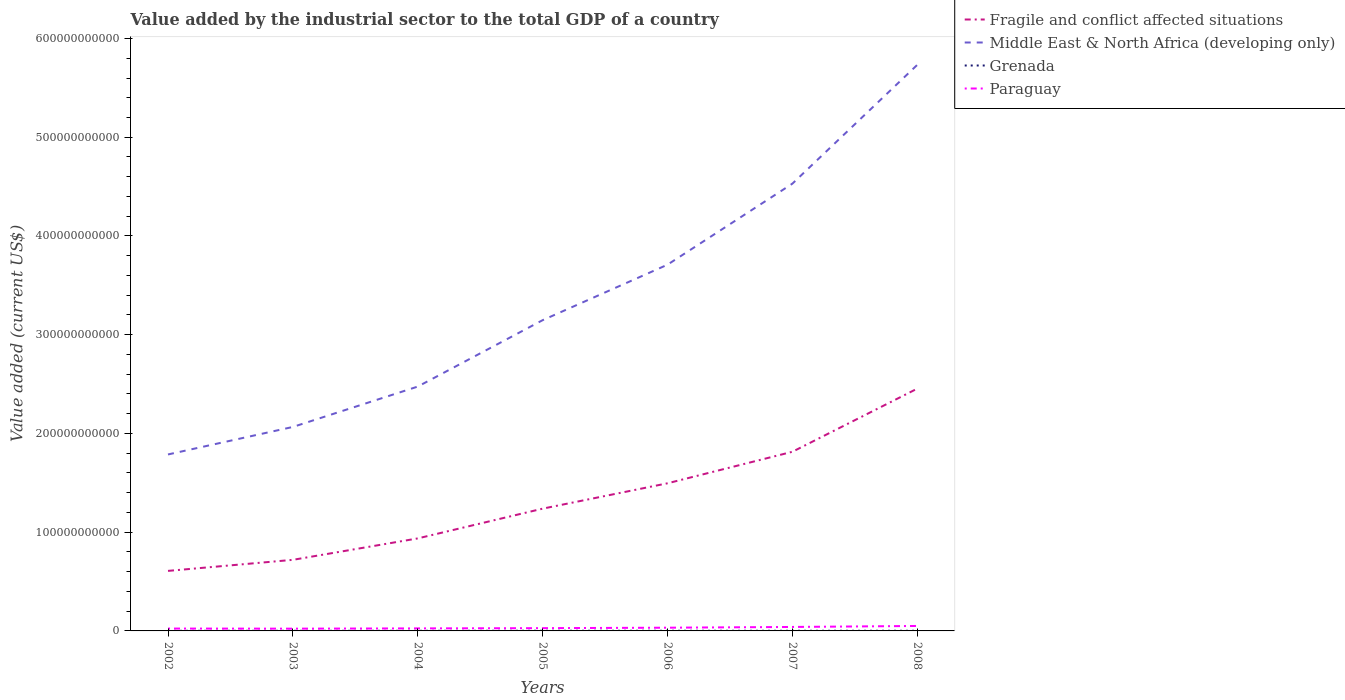How many different coloured lines are there?
Offer a terse response. 4. Is the number of lines equal to the number of legend labels?
Your answer should be very brief. Yes. Across all years, what is the maximum value added by the industrial sector to the total GDP in Paraguay?
Give a very brief answer. 2.29e+09. In which year was the value added by the industrial sector to the total GDP in Grenada maximum?
Your answer should be compact. 2002. What is the total value added by the industrial sector to the total GDP in Paraguay in the graph?
Your answer should be compact. -2.49e+08. What is the difference between the highest and the second highest value added by the industrial sector to the total GDP in Middle East & North Africa (developing only)?
Offer a very short reply. 3.95e+11. What is the difference between the highest and the lowest value added by the industrial sector to the total GDP in Grenada?
Provide a short and direct response. 4. Is the value added by the industrial sector to the total GDP in Fragile and conflict affected situations strictly greater than the value added by the industrial sector to the total GDP in Paraguay over the years?
Your response must be concise. No. How many lines are there?
Your response must be concise. 4. What is the difference between two consecutive major ticks on the Y-axis?
Your response must be concise. 1.00e+11. Does the graph contain any zero values?
Give a very brief answer. No. Does the graph contain grids?
Your answer should be compact. No. Where does the legend appear in the graph?
Provide a short and direct response. Top right. What is the title of the graph?
Ensure brevity in your answer.  Value added by the industrial sector to the total GDP of a country. What is the label or title of the Y-axis?
Your answer should be very brief. Value added (current US$). What is the Value added (current US$) of Fragile and conflict affected situations in 2002?
Offer a terse response. 6.08e+1. What is the Value added (current US$) of Middle East & North Africa (developing only) in 2002?
Give a very brief answer. 1.79e+11. What is the Value added (current US$) in Grenada in 2002?
Offer a very short reply. 8.98e+07. What is the Value added (current US$) of Paraguay in 2002?
Your answer should be very brief. 2.40e+09. What is the Value added (current US$) in Fragile and conflict affected situations in 2003?
Your response must be concise. 7.20e+1. What is the Value added (current US$) in Middle East & North Africa (developing only) in 2003?
Your answer should be very brief. 2.07e+11. What is the Value added (current US$) in Grenada in 2003?
Make the answer very short. 1.01e+08. What is the Value added (current US$) of Paraguay in 2003?
Ensure brevity in your answer.  2.29e+09. What is the Value added (current US$) in Fragile and conflict affected situations in 2004?
Provide a short and direct response. 9.37e+1. What is the Value added (current US$) of Middle East & North Africa (developing only) in 2004?
Your response must be concise. 2.47e+11. What is the Value added (current US$) in Grenada in 2004?
Keep it short and to the point. 1.00e+08. What is the Value added (current US$) in Paraguay in 2004?
Provide a short and direct response. 2.56e+09. What is the Value added (current US$) of Fragile and conflict affected situations in 2005?
Offer a very short reply. 1.24e+11. What is the Value added (current US$) of Middle East & North Africa (developing only) in 2005?
Provide a succinct answer. 3.15e+11. What is the Value added (current US$) in Grenada in 2005?
Offer a very short reply. 1.59e+08. What is the Value added (current US$) in Paraguay in 2005?
Keep it short and to the point. 2.81e+09. What is the Value added (current US$) of Fragile and conflict affected situations in 2006?
Your answer should be very brief. 1.50e+11. What is the Value added (current US$) in Middle East & North Africa (developing only) in 2006?
Offer a terse response. 3.71e+11. What is the Value added (current US$) of Grenada in 2006?
Keep it short and to the point. 1.36e+08. What is the Value added (current US$) of Paraguay in 2006?
Ensure brevity in your answer.  3.27e+09. What is the Value added (current US$) of Fragile and conflict affected situations in 2007?
Your answer should be very brief. 1.81e+11. What is the Value added (current US$) of Middle East & North Africa (developing only) in 2007?
Your answer should be very brief. 4.53e+11. What is the Value added (current US$) in Grenada in 2007?
Make the answer very short. 1.43e+08. What is the Value added (current US$) in Paraguay in 2007?
Your answer should be compact. 4.01e+09. What is the Value added (current US$) in Fragile and conflict affected situations in 2008?
Provide a succinct answer. 2.45e+11. What is the Value added (current US$) of Middle East & North Africa (developing only) in 2008?
Ensure brevity in your answer.  5.73e+11. What is the Value added (current US$) of Grenada in 2008?
Make the answer very short. 1.45e+08. What is the Value added (current US$) in Paraguay in 2008?
Your response must be concise. 5.03e+09. Across all years, what is the maximum Value added (current US$) of Fragile and conflict affected situations?
Ensure brevity in your answer.  2.45e+11. Across all years, what is the maximum Value added (current US$) of Middle East & North Africa (developing only)?
Provide a short and direct response. 5.73e+11. Across all years, what is the maximum Value added (current US$) in Grenada?
Make the answer very short. 1.59e+08. Across all years, what is the maximum Value added (current US$) in Paraguay?
Your response must be concise. 5.03e+09. Across all years, what is the minimum Value added (current US$) of Fragile and conflict affected situations?
Your answer should be compact. 6.08e+1. Across all years, what is the minimum Value added (current US$) in Middle East & North Africa (developing only)?
Your answer should be compact. 1.79e+11. Across all years, what is the minimum Value added (current US$) in Grenada?
Offer a very short reply. 8.98e+07. Across all years, what is the minimum Value added (current US$) in Paraguay?
Give a very brief answer. 2.29e+09. What is the total Value added (current US$) of Fragile and conflict affected situations in the graph?
Your response must be concise. 9.27e+11. What is the total Value added (current US$) of Middle East & North Africa (developing only) in the graph?
Give a very brief answer. 2.34e+12. What is the total Value added (current US$) in Grenada in the graph?
Offer a very short reply. 8.73e+08. What is the total Value added (current US$) in Paraguay in the graph?
Give a very brief answer. 2.24e+1. What is the difference between the Value added (current US$) of Fragile and conflict affected situations in 2002 and that in 2003?
Ensure brevity in your answer.  -1.12e+1. What is the difference between the Value added (current US$) in Middle East & North Africa (developing only) in 2002 and that in 2003?
Ensure brevity in your answer.  -2.79e+1. What is the difference between the Value added (current US$) of Grenada in 2002 and that in 2003?
Keep it short and to the point. -1.07e+07. What is the difference between the Value added (current US$) in Paraguay in 2002 and that in 2003?
Provide a succinct answer. 1.13e+08. What is the difference between the Value added (current US$) of Fragile and conflict affected situations in 2002 and that in 2004?
Offer a terse response. -3.29e+1. What is the difference between the Value added (current US$) of Middle East & North Africa (developing only) in 2002 and that in 2004?
Your answer should be very brief. -6.88e+1. What is the difference between the Value added (current US$) in Grenada in 2002 and that in 2004?
Ensure brevity in your answer.  -1.03e+07. What is the difference between the Value added (current US$) in Paraguay in 2002 and that in 2004?
Provide a succinct answer. -1.56e+08. What is the difference between the Value added (current US$) in Fragile and conflict affected situations in 2002 and that in 2005?
Provide a short and direct response. -6.30e+1. What is the difference between the Value added (current US$) in Middle East & North Africa (developing only) in 2002 and that in 2005?
Provide a succinct answer. -1.36e+11. What is the difference between the Value added (current US$) in Grenada in 2002 and that in 2005?
Provide a succinct answer. -6.91e+07. What is the difference between the Value added (current US$) of Paraguay in 2002 and that in 2005?
Make the answer very short. -4.05e+08. What is the difference between the Value added (current US$) in Fragile and conflict affected situations in 2002 and that in 2006?
Give a very brief answer. -8.87e+1. What is the difference between the Value added (current US$) in Middle East & North Africa (developing only) in 2002 and that in 2006?
Make the answer very short. -1.92e+11. What is the difference between the Value added (current US$) of Grenada in 2002 and that in 2006?
Offer a very short reply. -4.59e+07. What is the difference between the Value added (current US$) of Paraguay in 2002 and that in 2006?
Provide a short and direct response. -8.67e+08. What is the difference between the Value added (current US$) in Fragile and conflict affected situations in 2002 and that in 2007?
Your answer should be very brief. -1.21e+11. What is the difference between the Value added (current US$) of Middle East & North Africa (developing only) in 2002 and that in 2007?
Ensure brevity in your answer.  -2.74e+11. What is the difference between the Value added (current US$) in Grenada in 2002 and that in 2007?
Provide a succinct answer. -5.30e+07. What is the difference between the Value added (current US$) of Paraguay in 2002 and that in 2007?
Provide a short and direct response. -1.61e+09. What is the difference between the Value added (current US$) in Fragile and conflict affected situations in 2002 and that in 2008?
Ensure brevity in your answer.  -1.85e+11. What is the difference between the Value added (current US$) of Middle East & North Africa (developing only) in 2002 and that in 2008?
Provide a short and direct response. -3.95e+11. What is the difference between the Value added (current US$) in Grenada in 2002 and that in 2008?
Provide a short and direct response. -5.52e+07. What is the difference between the Value added (current US$) in Paraguay in 2002 and that in 2008?
Offer a terse response. -2.63e+09. What is the difference between the Value added (current US$) in Fragile and conflict affected situations in 2003 and that in 2004?
Offer a terse response. -2.17e+1. What is the difference between the Value added (current US$) of Middle East & North Africa (developing only) in 2003 and that in 2004?
Offer a very short reply. -4.09e+1. What is the difference between the Value added (current US$) of Grenada in 2003 and that in 2004?
Offer a very short reply. 4.01e+05. What is the difference between the Value added (current US$) in Paraguay in 2003 and that in 2004?
Your response must be concise. -2.69e+08. What is the difference between the Value added (current US$) in Fragile and conflict affected situations in 2003 and that in 2005?
Provide a short and direct response. -5.18e+1. What is the difference between the Value added (current US$) of Middle East & North Africa (developing only) in 2003 and that in 2005?
Offer a terse response. -1.08e+11. What is the difference between the Value added (current US$) in Grenada in 2003 and that in 2005?
Provide a short and direct response. -5.84e+07. What is the difference between the Value added (current US$) in Paraguay in 2003 and that in 2005?
Provide a short and direct response. -5.18e+08. What is the difference between the Value added (current US$) in Fragile and conflict affected situations in 2003 and that in 2006?
Ensure brevity in your answer.  -7.75e+1. What is the difference between the Value added (current US$) of Middle East & North Africa (developing only) in 2003 and that in 2006?
Keep it short and to the point. -1.64e+11. What is the difference between the Value added (current US$) in Grenada in 2003 and that in 2006?
Provide a short and direct response. -3.52e+07. What is the difference between the Value added (current US$) in Paraguay in 2003 and that in 2006?
Keep it short and to the point. -9.80e+08. What is the difference between the Value added (current US$) of Fragile and conflict affected situations in 2003 and that in 2007?
Ensure brevity in your answer.  -1.09e+11. What is the difference between the Value added (current US$) in Middle East & North Africa (developing only) in 2003 and that in 2007?
Keep it short and to the point. -2.46e+11. What is the difference between the Value added (current US$) of Grenada in 2003 and that in 2007?
Give a very brief answer. -4.22e+07. What is the difference between the Value added (current US$) in Paraguay in 2003 and that in 2007?
Provide a short and direct response. -1.73e+09. What is the difference between the Value added (current US$) in Fragile and conflict affected situations in 2003 and that in 2008?
Provide a succinct answer. -1.73e+11. What is the difference between the Value added (current US$) of Middle East & North Africa (developing only) in 2003 and that in 2008?
Give a very brief answer. -3.67e+11. What is the difference between the Value added (current US$) in Grenada in 2003 and that in 2008?
Your response must be concise. -4.45e+07. What is the difference between the Value added (current US$) of Paraguay in 2003 and that in 2008?
Provide a short and direct response. -2.74e+09. What is the difference between the Value added (current US$) in Fragile and conflict affected situations in 2004 and that in 2005?
Your answer should be compact. -3.01e+1. What is the difference between the Value added (current US$) of Middle East & North Africa (developing only) in 2004 and that in 2005?
Your answer should be very brief. -6.72e+1. What is the difference between the Value added (current US$) in Grenada in 2004 and that in 2005?
Ensure brevity in your answer.  -5.88e+07. What is the difference between the Value added (current US$) in Paraguay in 2004 and that in 2005?
Ensure brevity in your answer.  -2.49e+08. What is the difference between the Value added (current US$) of Fragile and conflict affected situations in 2004 and that in 2006?
Make the answer very short. -5.58e+1. What is the difference between the Value added (current US$) of Middle East & North Africa (developing only) in 2004 and that in 2006?
Ensure brevity in your answer.  -1.23e+11. What is the difference between the Value added (current US$) of Grenada in 2004 and that in 2006?
Your response must be concise. -3.56e+07. What is the difference between the Value added (current US$) in Paraguay in 2004 and that in 2006?
Provide a short and direct response. -7.11e+08. What is the difference between the Value added (current US$) in Fragile and conflict affected situations in 2004 and that in 2007?
Provide a succinct answer. -8.77e+1. What is the difference between the Value added (current US$) of Middle East & North Africa (developing only) in 2004 and that in 2007?
Ensure brevity in your answer.  -2.06e+11. What is the difference between the Value added (current US$) of Grenada in 2004 and that in 2007?
Keep it short and to the point. -4.26e+07. What is the difference between the Value added (current US$) in Paraguay in 2004 and that in 2007?
Make the answer very short. -1.46e+09. What is the difference between the Value added (current US$) of Fragile and conflict affected situations in 2004 and that in 2008?
Make the answer very short. -1.52e+11. What is the difference between the Value added (current US$) in Middle East & North Africa (developing only) in 2004 and that in 2008?
Keep it short and to the point. -3.26e+11. What is the difference between the Value added (current US$) in Grenada in 2004 and that in 2008?
Your answer should be very brief. -4.49e+07. What is the difference between the Value added (current US$) in Paraguay in 2004 and that in 2008?
Offer a terse response. -2.47e+09. What is the difference between the Value added (current US$) in Fragile and conflict affected situations in 2005 and that in 2006?
Your response must be concise. -2.57e+1. What is the difference between the Value added (current US$) of Middle East & North Africa (developing only) in 2005 and that in 2006?
Keep it short and to the point. -5.62e+1. What is the difference between the Value added (current US$) in Grenada in 2005 and that in 2006?
Ensure brevity in your answer.  2.32e+07. What is the difference between the Value added (current US$) in Paraguay in 2005 and that in 2006?
Your answer should be compact. -4.62e+08. What is the difference between the Value added (current US$) in Fragile and conflict affected situations in 2005 and that in 2007?
Offer a terse response. -5.76e+1. What is the difference between the Value added (current US$) of Middle East & North Africa (developing only) in 2005 and that in 2007?
Offer a very short reply. -1.38e+11. What is the difference between the Value added (current US$) of Grenada in 2005 and that in 2007?
Your answer should be compact. 1.61e+07. What is the difference between the Value added (current US$) of Paraguay in 2005 and that in 2007?
Offer a very short reply. -1.21e+09. What is the difference between the Value added (current US$) of Fragile and conflict affected situations in 2005 and that in 2008?
Offer a terse response. -1.22e+11. What is the difference between the Value added (current US$) of Middle East & North Africa (developing only) in 2005 and that in 2008?
Provide a succinct answer. -2.59e+11. What is the difference between the Value added (current US$) in Grenada in 2005 and that in 2008?
Your answer should be compact. 1.39e+07. What is the difference between the Value added (current US$) of Paraguay in 2005 and that in 2008?
Make the answer very short. -2.22e+09. What is the difference between the Value added (current US$) in Fragile and conflict affected situations in 2006 and that in 2007?
Your answer should be very brief. -3.19e+1. What is the difference between the Value added (current US$) of Middle East & North Africa (developing only) in 2006 and that in 2007?
Ensure brevity in your answer.  -8.20e+1. What is the difference between the Value added (current US$) in Grenada in 2006 and that in 2007?
Offer a very short reply. -7.07e+06. What is the difference between the Value added (current US$) of Paraguay in 2006 and that in 2007?
Provide a succinct answer. -7.46e+08. What is the difference between the Value added (current US$) of Fragile and conflict affected situations in 2006 and that in 2008?
Your answer should be compact. -9.59e+1. What is the difference between the Value added (current US$) of Middle East & North Africa (developing only) in 2006 and that in 2008?
Offer a terse response. -2.02e+11. What is the difference between the Value added (current US$) in Grenada in 2006 and that in 2008?
Offer a very short reply. -9.29e+06. What is the difference between the Value added (current US$) in Paraguay in 2006 and that in 2008?
Provide a short and direct response. -1.76e+09. What is the difference between the Value added (current US$) of Fragile and conflict affected situations in 2007 and that in 2008?
Give a very brief answer. -6.40e+1. What is the difference between the Value added (current US$) of Middle East & North Africa (developing only) in 2007 and that in 2008?
Make the answer very short. -1.20e+11. What is the difference between the Value added (current US$) in Grenada in 2007 and that in 2008?
Keep it short and to the point. -2.22e+06. What is the difference between the Value added (current US$) in Paraguay in 2007 and that in 2008?
Your answer should be very brief. -1.01e+09. What is the difference between the Value added (current US$) of Fragile and conflict affected situations in 2002 and the Value added (current US$) of Middle East & North Africa (developing only) in 2003?
Ensure brevity in your answer.  -1.46e+11. What is the difference between the Value added (current US$) in Fragile and conflict affected situations in 2002 and the Value added (current US$) in Grenada in 2003?
Offer a terse response. 6.07e+1. What is the difference between the Value added (current US$) in Fragile and conflict affected situations in 2002 and the Value added (current US$) in Paraguay in 2003?
Keep it short and to the point. 5.85e+1. What is the difference between the Value added (current US$) in Middle East & North Africa (developing only) in 2002 and the Value added (current US$) in Grenada in 2003?
Ensure brevity in your answer.  1.79e+11. What is the difference between the Value added (current US$) of Middle East & North Africa (developing only) in 2002 and the Value added (current US$) of Paraguay in 2003?
Ensure brevity in your answer.  1.76e+11. What is the difference between the Value added (current US$) of Grenada in 2002 and the Value added (current US$) of Paraguay in 2003?
Your answer should be compact. -2.20e+09. What is the difference between the Value added (current US$) in Fragile and conflict affected situations in 2002 and the Value added (current US$) in Middle East & North Africa (developing only) in 2004?
Provide a short and direct response. -1.87e+11. What is the difference between the Value added (current US$) of Fragile and conflict affected situations in 2002 and the Value added (current US$) of Grenada in 2004?
Offer a very short reply. 6.07e+1. What is the difference between the Value added (current US$) in Fragile and conflict affected situations in 2002 and the Value added (current US$) in Paraguay in 2004?
Your response must be concise. 5.82e+1. What is the difference between the Value added (current US$) in Middle East & North Africa (developing only) in 2002 and the Value added (current US$) in Grenada in 2004?
Provide a succinct answer. 1.79e+11. What is the difference between the Value added (current US$) in Middle East & North Africa (developing only) in 2002 and the Value added (current US$) in Paraguay in 2004?
Offer a terse response. 1.76e+11. What is the difference between the Value added (current US$) in Grenada in 2002 and the Value added (current US$) in Paraguay in 2004?
Ensure brevity in your answer.  -2.47e+09. What is the difference between the Value added (current US$) in Fragile and conflict affected situations in 2002 and the Value added (current US$) in Middle East & North Africa (developing only) in 2005?
Give a very brief answer. -2.54e+11. What is the difference between the Value added (current US$) in Fragile and conflict affected situations in 2002 and the Value added (current US$) in Grenada in 2005?
Ensure brevity in your answer.  6.06e+1. What is the difference between the Value added (current US$) in Fragile and conflict affected situations in 2002 and the Value added (current US$) in Paraguay in 2005?
Your answer should be compact. 5.80e+1. What is the difference between the Value added (current US$) of Middle East & North Africa (developing only) in 2002 and the Value added (current US$) of Grenada in 2005?
Your response must be concise. 1.79e+11. What is the difference between the Value added (current US$) of Middle East & North Africa (developing only) in 2002 and the Value added (current US$) of Paraguay in 2005?
Offer a very short reply. 1.76e+11. What is the difference between the Value added (current US$) of Grenada in 2002 and the Value added (current US$) of Paraguay in 2005?
Ensure brevity in your answer.  -2.72e+09. What is the difference between the Value added (current US$) of Fragile and conflict affected situations in 2002 and the Value added (current US$) of Middle East & North Africa (developing only) in 2006?
Provide a succinct answer. -3.10e+11. What is the difference between the Value added (current US$) in Fragile and conflict affected situations in 2002 and the Value added (current US$) in Grenada in 2006?
Provide a short and direct response. 6.07e+1. What is the difference between the Value added (current US$) in Fragile and conflict affected situations in 2002 and the Value added (current US$) in Paraguay in 2006?
Keep it short and to the point. 5.75e+1. What is the difference between the Value added (current US$) in Middle East & North Africa (developing only) in 2002 and the Value added (current US$) in Grenada in 2006?
Your answer should be very brief. 1.79e+11. What is the difference between the Value added (current US$) in Middle East & North Africa (developing only) in 2002 and the Value added (current US$) in Paraguay in 2006?
Provide a succinct answer. 1.75e+11. What is the difference between the Value added (current US$) in Grenada in 2002 and the Value added (current US$) in Paraguay in 2006?
Offer a very short reply. -3.18e+09. What is the difference between the Value added (current US$) of Fragile and conflict affected situations in 2002 and the Value added (current US$) of Middle East & North Africa (developing only) in 2007?
Provide a succinct answer. -3.92e+11. What is the difference between the Value added (current US$) of Fragile and conflict affected situations in 2002 and the Value added (current US$) of Grenada in 2007?
Provide a succinct answer. 6.07e+1. What is the difference between the Value added (current US$) of Fragile and conflict affected situations in 2002 and the Value added (current US$) of Paraguay in 2007?
Provide a short and direct response. 5.68e+1. What is the difference between the Value added (current US$) in Middle East & North Africa (developing only) in 2002 and the Value added (current US$) in Grenada in 2007?
Your response must be concise. 1.79e+11. What is the difference between the Value added (current US$) in Middle East & North Africa (developing only) in 2002 and the Value added (current US$) in Paraguay in 2007?
Give a very brief answer. 1.75e+11. What is the difference between the Value added (current US$) of Grenada in 2002 and the Value added (current US$) of Paraguay in 2007?
Provide a succinct answer. -3.92e+09. What is the difference between the Value added (current US$) of Fragile and conflict affected situations in 2002 and the Value added (current US$) of Middle East & North Africa (developing only) in 2008?
Keep it short and to the point. -5.13e+11. What is the difference between the Value added (current US$) in Fragile and conflict affected situations in 2002 and the Value added (current US$) in Grenada in 2008?
Ensure brevity in your answer.  6.07e+1. What is the difference between the Value added (current US$) in Fragile and conflict affected situations in 2002 and the Value added (current US$) in Paraguay in 2008?
Provide a short and direct response. 5.58e+1. What is the difference between the Value added (current US$) in Middle East & North Africa (developing only) in 2002 and the Value added (current US$) in Grenada in 2008?
Offer a very short reply. 1.79e+11. What is the difference between the Value added (current US$) in Middle East & North Africa (developing only) in 2002 and the Value added (current US$) in Paraguay in 2008?
Your answer should be compact. 1.74e+11. What is the difference between the Value added (current US$) in Grenada in 2002 and the Value added (current US$) in Paraguay in 2008?
Your answer should be compact. -4.94e+09. What is the difference between the Value added (current US$) in Fragile and conflict affected situations in 2003 and the Value added (current US$) in Middle East & North Africa (developing only) in 2004?
Offer a very short reply. -1.75e+11. What is the difference between the Value added (current US$) in Fragile and conflict affected situations in 2003 and the Value added (current US$) in Grenada in 2004?
Make the answer very short. 7.19e+1. What is the difference between the Value added (current US$) in Fragile and conflict affected situations in 2003 and the Value added (current US$) in Paraguay in 2004?
Your response must be concise. 6.94e+1. What is the difference between the Value added (current US$) of Middle East & North Africa (developing only) in 2003 and the Value added (current US$) of Grenada in 2004?
Keep it short and to the point. 2.06e+11. What is the difference between the Value added (current US$) in Middle East & North Africa (developing only) in 2003 and the Value added (current US$) in Paraguay in 2004?
Your response must be concise. 2.04e+11. What is the difference between the Value added (current US$) of Grenada in 2003 and the Value added (current US$) of Paraguay in 2004?
Ensure brevity in your answer.  -2.46e+09. What is the difference between the Value added (current US$) in Fragile and conflict affected situations in 2003 and the Value added (current US$) in Middle East & North Africa (developing only) in 2005?
Your answer should be compact. -2.43e+11. What is the difference between the Value added (current US$) in Fragile and conflict affected situations in 2003 and the Value added (current US$) in Grenada in 2005?
Give a very brief answer. 7.18e+1. What is the difference between the Value added (current US$) of Fragile and conflict affected situations in 2003 and the Value added (current US$) of Paraguay in 2005?
Your answer should be compact. 6.92e+1. What is the difference between the Value added (current US$) of Middle East & North Africa (developing only) in 2003 and the Value added (current US$) of Grenada in 2005?
Provide a succinct answer. 2.06e+11. What is the difference between the Value added (current US$) in Middle East & North Africa (developing only) in 2003 and the Value added (current US$) in Paraguay in 2005?
Make the answer very short. 2.04e+11. What is the difference between the Value added (current US$) in Grenada in 2003 and the Value added (current US$) in Paraguay in 2005?
Ensure brevity in your answer.  -2.71e+09. What is the difference between the Value added (current US$) of Fragile and conflict affected situations in 2003 and the Value added (current US$) of Middle East & North Africa (developing only) in 2006?
Give a very brief answer. -2.99e+11. What is the difference between the Value added (current US$) of Fragile and conflict affected situations in 2003 and the Value added (current US$) of Grenada in 2006?
Offer a very short reply. 7.19e+1. What is the difference between the Value added (current US$) in Fragile and conflict affected situations in 2003 and the Value added (current US$) in Paraguay in 2006?
Make the answer very short. 6.87e+1. What is the difference between the Value added (current US$) of Middle East & North Africa (developing only) in 2003 and the Value added (current US$) of Grenada in 2006?
Your answer should be compact. 2.06e+11. What is the difference between the Value added (current US$) of Middle East & North Africa (developing only) in 2003 and the Value added (current US$) of Paraguay in 2006?
Offer a terse response. 2.03e+11. What is the difference between the Value added (current US$) of Grenada in 2003 and the Value added (current US$) of Paraguay in 2006?
Your response must be concise. -3.17e+09. What is the difference between the Value added (current US$) of Fragile and conflict affected situations in 2003 and the Value added (current US$) of Middle East & North Africa (developing only) in 2007?
Your answer should be very brief. -3.81e+11. What is the difference between the Value added (current US$) in Fragile and conflict affected situations in 2003 and the Value added (current US$) in Grenada in 2007?
Provide a short and direct response. 7.19e+1. What is the difference between the Value added (current US$) in Fragile and conflict affected situations in 2003 and the Value added (current US$) in Paraguay in 2007?
Keep it short and to the point. 6.80e+1. What is the difference between the Value added (current US$) in Middle East & North Africa (developing only) in 2003 and the Value added (current US$) in Grenada in 2007?
Your response must be concise. 2.06e+11. What is the difference between the Value added (current US$) in Middle East & North Africa (developing only) in 2003 and the Value added (current US$) in Paraguay in 2007?
Provide a succinct answer. 2.03e+11. What is the difference between the Value added (current US$) in Grenada in 2003 and the Value added (current US$) in Paraguay in 2007?
Your response must be concise. -3.91e+09. What is the difference between the Value added (current US$) in Fragile and conflict affected situations in 2003 and the Value added (current US$) in Middle East & North Africa (developing only) in 2008?
Keep it short and to the point. -5.01e+11. What is the difference between the Value added (current US$) of Fragile and conflict affected situations in 2003 and the Value added (current US$) of Grenada in 2008?
Ensure brevity in your answer.  7.19e+1. What is the difference between the Value added (current US$) of Fragile and conflict affected situations in 2003 and the Value added (current US$) of Paraguay in 2008?
Your answer should be very brief. 6.70e+1. What is the difference between the Value added (current US$) of Middle East & North Africa (developing only) in 2003 and the Value added (current US$) of Grenada in 2008?
Offer a terse response. 2.06e+11. What is the difference between the Value added (current US$) of Middle East & North Africa (developing only) in 2003 and the Value added (current US$) of Paraguay in 2008?
Ensure brevity in your answer.  2.02e+11. What is the difference between the Value added (current US$) of Grenada in 2003 and the Value added (current US$) of Paraguay in 2008?
Your answer should be compact. -4.93e+09. What is the difference between the Value added (current US$) in Fragile and conflict affected situations in 2004 and the Value added (current US$) in Middle East & North Africa (developing only) in 2005?
Offer a terse response. -2.21e+11. What is the difference between the Value added (current US$) of Fragile and conflict affected situations in 2004 and the Value added (current US$) of Grenada in 2005?
Your response must be concise. 9.35e+1. What is the difference between the Value added (current US$) of Fragile and conflict affected situations in 2004 and the Value added (current US$) of Paraguay in 2005?
Provide a succinct answer. 9.09e+1. What is the difference between the Value added (current US$) in Middle East & North Africa (developing only) in 2004 and the Value added (current US$) in Grenada in 2005?
Offer a very short reply. 2.47e+11. What is the difference between the Value added (current US$) of Middle East & North Africa (developing only) in 2004 and the Value added (current US$) of Paraguay in 2005?
Your response must be concise. 2.45e+11. What is the difference between the Value added (current US$) in Grenada in 2004 and the Value added (current US$) in Paraguay in 2005?
Your answer should be very brief. -2.71e+09. What is the difference between the Value added (current US$) of Fragile and conflict affected situations in 2004 and the Value added (current US$) of Middle East & North Africa (developing only) in 2006?
Provide a short and direct response. -2.77e+11. What is the difference between the Value added (current US$) in Fragile and conflict affected situations in 2004 and the Value added (current US$) in Grenada in 2006?
Ensure brevity in your answer.  9.36e+1. What is the difference between the Value added (current US$) of Fragile and conflict affected situations in 2004 and the Value added (current US$) of Paraguay in 2006?
Your answer should be very brief. 9.04e+1. What is the difference between the Value added (current US$) in Middle East & North Africa (developing only) in 2004 and the Value added (current US$) in Grenada in 2006?
Make the answer very short. 2.47e+11. What is the difference between the Value added (current US$) of Middle East & North Africa (developing only) in 2004 and the Value added (current US$) of Paraguay in 2006?
Provide a succinct answer. 2.44e+11. What is the difference between the Value added (current US$) of Grenada in 2004 and the Value added (current US$) of Paraguay in 2006?
Offer a terse response. -3.17e+09. What is the difference between the Value added (current US$) of Fragile and conflict affected situations in 2004 and the Value added (current US$) of Middle East & North Africa (developing only) in 2007?
Keep it short and to the point. -3.59e+11. What is the difference between the Value added (current US$) of Fragile and conflict affected situations in 2004 and the Value added (current US$) of Grenada in 2007?
Make the answer very short. 9.36e+1. What is the difference between the Value added (current US$) in Fragile and conflict affected situations in 2004 and the Value added (current US$) in Paraguay in 2007?
Your answer should be very brief. 8.97e+1. What is the difference between the Value added (current US$) of Middle East & North Africa (developing only) in 2004 and the Value added (current US$) of Grenada in 2007?
Your response must be concise. 2.47e+11. What is the difference between the Value added (current US$) in Middle East & North Africa (developing only) in 2004 and the Value added (current US$) in Paraguay in 2007?
Offer a very short reply. 2.43e+11. What is the difference between the Value added (current US$) in Grenada in 2004 and the Value added (current US$) in Paraguay in 2007?
Offer a terse response. -3.91e+09. What is the difference between the Value added (current US$) of Fragile and conflict affected situations in 2004 and the Value added (current US$) of Middle East & North Africa (developing only) in 2008?
Ensure brevity in your answer.  -4.80e+11. What is the difference between the Value added (current US$) of Fragile and conflict affected situations in 2004 and the Value added (current US$) of Grenada in 2008?
Your response must be concise. 9.36e+1. What is the difference between the Value added (current US$) of Fragile and conflict affected situations in 2004 and the Value added (current US$) of Paraguay in 2008?
Give a very brief answer. 8.87e+1. What is the difference between the Value added (current US$) in Middle East & North Africa (developing only) in 2004 and the Value added (current US$) in Grenada in 2008?
Your answer should be compact. 2.47e+11. What is the difference between the Value added (current US$) of Middle East & North Africa (developing only) in 2004 and the Value added (current US$) of Paraguay in 2008?
Your answer should be compact. 2.42e+11. What is the difference between the Value added (current US$) of Grenada in 2004 and the Value added (current US$) of Paraguay in 2008?
Give a very brief answer. -4.93e+09. What is the difference between the Value added (current US$) of Fragile and conflict affected situations in 2005 and the Value added (current US$) of Middle East & North Africa (developing only) in 2006?
Give a very brief answer. -2.47e+11. What is the difference between the Value added (current US$) in Fragile and conflict affected situations in 2005 and the Value added (current US$) in Grenada in 2006?
Your answer should be compact. 1.24e+11. What is the difference between the Value added (current US$) in Fragile and conflict affected situations in 2005 and the Value added (current US$) in Paraguay in 2006?
Offer a terse response. 1.21e+11. What is the difference between the Value added (current US$) in Middle East & North Africa (developing only) in 2005 and the Value added (current US$) in Grenada in 2006?
Offer a very short reply. 3.15e+11. What is the difference between the Value added (current US$) of Middle East & North Africa (developing only) in 2005 and the Value added (current US$) of Paraguay in 2006?
Ensure brevity in your answer.  3.11e+11. What is the difference between the Value added (current US$) of Grenada in 2005 and the Value added (current US$) of Paraguay in 2006?
Provide a short and direct response. -3.11e+09. What is the difference between the Value added (current US$) of Fragile and conflict affected situations in 2005 and the Value added (current US$) of Middle East & North Africa (developing only) in 2007?
Your response must be concise. -3.29e+11. What is the difference between the Value added (current US$) of Fragile and conflict affected situations in 2005 and the Value added (current US$) of Grenada in 2007?
Offer a very short reply. 1.24e+11. What is the difference between the Value added (current US$) in Fragile and conflict affected situations in 2005 and the Value added (current US$) in Paraguay in 2007?
Provide a short and direct response. 1.20e+11. What is the difference between the Value added (current US$) of Middle East & North Africa (developing only) in 2005 and the Value added (current US$) of Grenada in 2007?
Provide a succinct answer. 3.15e+11. What is the difference between the Value added (current US$) of Middle East & North Africa (developing only) in 2005 and the Value added (current US$) of Paraguay in 2007?
Your response must be concise. 3.11e+11. What is the difference between the Value added (current US$) of Grenada in 2005 and the Value added (current US$) of Paraguay in 2007?
Give a very brief answer. -3.86e+09. What is the difference between the Value added (current US$) of Fragile and conflict affected situations in 2005 and the Value added (current US$) of Middle East & North Africa (developing only) in 2008?
Provide a succinct answer. -4.49e+11. What is the difference between the Value added (current US$) of Fragile and conflict affected situations in 2005 and the Value added (current US$) of Grenada in 2008?
Offer a terse response. 1.24e+11. What is the difference between the Value added (current US$) of Fragile and conflict affected situations in 2005 and the Value added (current US$) of Paraguay in 2008?
Provide a short and direct response. 1.19e+11. What is the difference between the Value added (current US$) in Middle East & North Africa (developing only) in 2005 and the Value added (current US$) in Grenada in 2008?
Provide a succinct answer. 3.15e+11. What is the difference between the Value added (current US$) in Middle East & North Africa (developing only) in 2005 and the Value added (current US$) in Paraguay in 2008?
Offer a terse response. 3.10e+11. What is the difference between the Value added (current US$) of Grenada in 2005 and the Value added (current US$) of Paraguay in 2008?
Keep it short and to the point. -4.87e+09. What is the difference between the Value added (current US$) of Fragile and conflict affected situations in 2006 and the Value added (current US$) of Middle East & North Africa (developing only) in 2007?
Your answer should be very brief. -3.03e+11. What is the difference between the Value added (current US$) of Fragile and conflict affected situations in 2006 and the Value added (current US$) of Grenada in 2007?
Offer a terse response. 1.49e+11. What is the difference between the Value added (current US$) in Fragile and conflict affected situations in 2006 and the Value added (current US$) in Paraguay in 2007?
Ensure brevity in your answer.  1.46e+11. What is the difference between the Value added (current US$) of Middle East & North Africa (developing only) in 2006 and the Value added (current US$) of Grenada in 2007?
Offer a very short reply. 3.71e+11. What is the difference between the Value added (current US$) in Middle East & North Africa (developing only) in 2006 and the Value added (current US$) in Paraguay in 2007?
Ensure brevity in your answer.  3.67e+11. What is the difference between the Value added (current US$) of Grenada in 2006 and the Value added (current US$) of Paraguay in 2007?
Ensure brevity in your answer.  -3.88e+09. What is the difference between the Value added (current US$) in Fragile and conflict affected situations in 2006 and the Value added (current US$) in Middle East & North Africa (developing only) in 2008?
Ensure brevity in your answer.  -4.24e+11. What is the difference between the Value added (current US$) in Fragile and conflict affected situations in 2006 and the Value added (current US$) in Grenada in 2008?
Offer a terse response. 1.49e+11. What is the difference between the Value added (current US$) of Fragile and conflict affected situations in 2006 and the Value added (current US$) of Paraguay in 2008?
Keep it short and to the point. 1.44e+11. What is the difference between the Value added (current US$) of Middle East & North Africa (developing only) in 2006 and the Value added (current US$) of Grenada in 2008?
Provide a succinct answer. 3.71e+11. What is the difference between the Value added (current US$) of Middle East & North Africa (developing only) in 2006 and the Value added (current US$) of Paraguay in 2008?
Provide a short and direct response. 3.66e+11. What is the difference between the Value added (current US$) of Grenada in 2006 and the Value added (current US$) of Paraguay in 2008?
Make the answer very short. -4.89e+09. What is the difference between the Value added (current US$) in Fragile and conflict affected situations in 2007 and the Value added (current US$) in Middle East & North Africa (developing only) in 2008?
Make the answer very short. -3.92e+11. What is the difference between the Value added (current US$) of Fragile and conflict affected situations in 2007 and the Value added (current US$) of Grenada in 2008?
Keep it short and to the point. 1.81e+11. What is the difference between the Value added (current US$) in Fragile and conflict affected situations in 2007 and the Value added (current US$) in Paraguay in 2008?
Offer a terse response. 1.76e+11. What is the difference between the Value added (current US$) in Middle East & North Africa (developing only) in 2007 and the Value added (current US$) in Grenada in 2008?
Keep it short and to the point. 4.53e+11. What is the difference between the Value added (current US$) of Middle East & North Africa (developing only) in 2007 and the Value added (current US$) of Paraguay in 2008?
Offer a terse response. 4.48e+11. What is the difference between the Value added (current US$) in Grenada in 2007 and the Value added (current US$) in Paraguay in 2008?
Provide a succinct answer. -4.89e+09. What is the average Value added (current US$) in Fragile and conflict affected situations per year?
Ensure brevity in your answer.  1.32e+11. What is the average Value added (current US$) in Middle East & North Africa (developing only) per year?
Give a very brief answer. 3.35e+11. What is the average Value added (current US$) of Grenada per year?
Offer a terse response. 1.25e+08. What is the average Value added (current US$) of Paraguay per year?
Provide a short and direct response. 3.19e+09. In the year 2002, what is the difference between the Value added (current US$) of Fragile and conflict affected situations and Value added (current US$) of Middle East & North Africa (developing only)?
Provide a succinct answer. -1.18e+11. In the year 2002, what is the difference between the Value added (current US$) of Fragile and conflict affected situations and Value added (current US$) of Grenada?
Offer a very short reply. 6.07e+1. In the year 2002, what is the difference between the Value added (current US$) in Fragile and conflict affected situations and Value added (current US$) in Paraguay?
Ensure brevity in your answer.  5.84e+1. In the year 2002, what is the difference between the Value added (current US$) in Middle East & North Africa (developing only) and Value added (current US$) in Grenada?
Offer a terse response. 1.79e+11. In the year 2002, what is the difference between the Value added (current US$) in Middle East & North Africa (developing only) and Value added (current US$) in Paraguay?
Provide a short and direct response. 1.76e+11. In the year 2002, what is the difference between the Value added (current US$) of Grenada and Value added (current US$) of Paraguay?
Give a very brief answer. -2.31e+09. In the year 2003, what is the difference between the Value added (current US$) in Fragile and conflict affected situations and Value added (current US$) in Middle East & North Africa (developing only)?
Keep it short and to the point. -1.35e+11. In the year 2003, what is the difference between the Value added (current US$) of Fragile and conflict affected situations and Value added (current US$) of Grenada?
Provide a succinct answer. 7.19e+1. In the year 2003, what is the difference between the Value added (current US$) in Fragile and conflict affected situations and Value added (current US$) in Paraguay?
Your answer should be compact. 6.97e+1. In the year 2003, what is the difference between the Value added (current US$) in Middle East & North Africa (developing only) and Value added (current US$) in Grenada?
Offer a terse response. 2.06e+11. In the year 2003, what is the difference between the Value added (current US$) of Middle East & North Africa (developing only) and Value added (current US$) of Paraguay?
Provide a succinct answer. 2.04e+11. In the year 2003, what is the difference between the Value added (current US$) of Grenada and Value added (current US$) of Paraguay?
Provide a succinct answer. -2.19e+09. In the year 2004, what is the difference between the Value added (current US$) in Fragile and conflict affected situations and Value added (current US$) in Middle East & North Africa (developing only)?
Provide a short and direct response. -1.54e+11. In the year 2004, what is the difference between the Value added (current US$) in Fragile and conflict affected situations and Value added (current US$) in Grenada?
Provide a succinct answer. 9.36e+1. In the year 2004, what is the difference between the Value added (current US$) in Fragile and conflict affected situations and Value added (current US$) in Paraguay?
Provide a short and direct response. 9.11e+1. In the year 2004, what is the difference between the Value added (current US$) of Middle East & North Africa (developing only) and Value added (current US$) of Grenada?
Your answer should be compact. 2.47e+11. In the year 2004, what is the difference between the Value added (current US$) of Middle East & North Africa (developing only) and Value added (current US$) of Paraguay?
Ensure brevity in your answer.  2.45e+11. In the year 2004, what is the difference between the Value added (current US$) of Grenada and Value added (current US$) of Paraguay?
Provide a succinct answer. -2.46e+09. In the year 2005, what is the difference between the Value added (current US$) in Fragile and conflict affected situations and Value added (current US$) in Middle East & North Africa (developing only)?
Provide a short and direct response. -1.91e+11. In the year 2005, what is the difference between the Value added (current US$) in Fragile and conflict affected situations and Value added (current US$) in Grenada?
Offer a very short reply. 1.24e+11. In the year 2005, what is the difference between the Value added (current US$) in Fragile and conflict affected situations and Value added (current US$) in Paraguay?
Ensure brevity in your answer.  1.21e+11. In the year 2005, what is the difference between the Value added (current US$) of Middle East & North Africa (developing only) and Value added (current US$) of Grenada?
Keep it short and to the point. 3.15e+11. In the year 2005, what is the difference between the Value added (current US$) of Middle East & North Africa (developing only) and Value added (current US$) of Paraguay?
Ensure brevity in your answer.  3.12e+11. In the year 2005, what is the difference between the Value added (current US$) in Grenada and Value added (current US$) in Paraguay?
Offer a terse response. -2.65e+09. In the year 2006, what is the difference between the Value added (current US$) of Fragile and conflict affected situations and Value added (current US$) of Middle East & North Africa (developing only)?
Your answer should be very brief. -2.21e+11. In the year 2006, what is the difference between the Value added (current US$) of Fragile and conflict affected situations and Value added (current US$) of Grenada?
Offer a very short reply. 1.49e+11. In the year 2006, what is the difference between the Value added (current US$) in Fragile and conflict affected situations and Value added (current US$) in Paraguay?
Your answer should be compact. 1.46e+11. In the year 2006, what is the difference between the Value added (current US$) in Middle East & North Africa (developing only) and Value added (current US$) in Grenada?
Your response must be concise. 3.71e+11. In the year 2006, what is the difference between the Value added (current US$) in Middle East & North Africa (developing only) and Value added (current US$) in Paraguay?
Give a very brief answer. 3.68e+11. In the year 2006, what is the difference between the Value added (current US$) of Grenada and Value added (current US$) of Paraguay?
Your answer should be compact. -3.13e+09. In the year 2007, what is the difference between the Value added (current US$) in Fragile and conflict affected situations and Value added (current US$) in Middle East & North Africa (developing only)?
Offer a terse response. -2.72e+11. In the year 2007, what is the difference between the Value added (current US$) in Fragile and conflict affected situations and Value added (current US$) in Grenada?
Make the answer very short. 1.81e+11. In the year 2007, what is the difference between the Value added (current US$) in Fragile and conflict affected situations and Value added (current US$) in Paraguay?
Provide a succinct answer. 1.77e+11. In the year 2007, what is the difference between the Value added (current US$) of Middle East & North Africa (developing only) and Value added (current US$) of Grenada?
Offer a terse response. 4.53e+11. In the year 2007, what is the difference between the Value added (current US$) of Middle East & North Africa (developing only) and Value added (current US$) of Paraguay?
Provide a succinct answer. 4.49e+11. In the year 2007, what is the difference between the Value added (current US$) of Grenada and Value added (current US$) of Paraguay?
Ensure brevity in your answer.  -3.87e+09. In the year 2008, what is the difference between the Value added (current US$) in Fragile and conflict affected situations and Value added (current US$) in Middle East & North Africa (developing only)?
Your answer should be compact. -3.28e+11. In the year 2008, what is the difference between the Value added (current US$) in Fragile and conflict affected situations and Value added (current US$) in Grenada?
Your answer should be very brief. 2.45e+11. In the year 2008, what is the difference between the Value added (current US$) in Fragile and conflict affected situations and Value added (current US$) in Paraguay?
Your response must be concise. 2.40e+11. In the year 2008, what is the difference between the Value added (current US$) in Middle East & North Africa (developing only) and Value added (current US$) in Grenada?
Your answer should be compact. 5.73e+11. In the year 2008, what is the difference between the Value added (current US$) of Middle East & North Africa (developing only) and Value added (current US$) of Paraguay?
Provide a short and direct response. 5.68e+11. In the year 2008, what is the difference between the Value added (current US$) in Grenada and Value added (current US$) in Paraguay?
Offer a terse response. -4.88e+09. What is the ratio of the Value added (current US$) in Fragile and conflict affected situations in 2002 to that in 2003?
Give a very brief answer. 0.84. What is the ratio of the Value added (current US$) in Middle East & North Africa (developing only) in 2002 to that in 2003?
Your answer should be very brief. 0.87. What is the ratio of the Value added (current US$) in Grenada in 2002 to that in 2003?
Provide a short and direct response. 0.89. What is the ratio of the Value added (current US$) in Paraguay in 2002 to that in 2003?
Make the answer very short. 1.05. What is the ratio of the Value added (current US$) in Fragile and conflict affected situations in 2002 to that in 2004?
Keep it short and to the point. 0.65. What is the ratio of the Value added (current US$) in Middle East & North Africa (developing only) in 2002 to that in 2004?
Your answer should be compact. 0.72. What is the ratio of the Value added (current US$) of Grenada in 2002 to that in 2004?
Your response must be concise. 0.9. What is the ratio of the Value added (current US$) of Paraguay in 2002 to that in 2004?
Your response must be concise. 0.94. What is the ratio of the Value added (current US$) in Fragile and conflict affected situations in 2002 to that in 2005?
Ensure brevity in your answer.  0.49. What is the ratio of the Value added (current US$) in Middle East & North Africa (developing only) in 2002 to that in 2005?
Provide a short and direct response. 0.57. What is the ratio of the Value added (current US$) in Grenada in 2002 to that in 2005?
Make the answer very short. 0.56. What is the ratio of the Value added (current US$) of Paraguay in 2002 to that in 2005?
Make the answer very short. 0.86. What is the ratio of the Value added (current US$) of Fragile and conflict affected situations in 2002 to that in 2006?
Provide a short and direct response. 0.41. What is the ratio of the Value added (current US$) of Middle East & North Africa (developing only) in 2002 to that in 2006?
Make the answer very short. 0.48. What is the ratio of the Value added (current US$) in Grenada in 2002 to that in 2006?
Make the answer very short. 0.66. What is the ratio of the Value added (current US$) in Paraguay in 2002 to that in 2006?
Ensure brevity in your answer.  0.73. What is the ratio of the Value added (current US$) of Fragile and conflict affected situations in 2002 to that in 2007?
Offer a very short reply. 0.34. What is the ratio of the Value added (current US$) in Middle East & North Africa (developing only) in 2002 to that in 2007?
Make the answer very short. 0.39. What is the ratio of the Value added (current US$) in Grenada in 2002 to that in 2007?
Offer a terse response. 0.63. What is the ratio of the Value added (current US$) in Paraguay in 2002 to that in 2007?
Ensure brevity in your answer.  0.6. What is the ratio of the Value added (current US$) of Fragile and conflict affected situations in 2002 to that in 2008?
Your answer should be very brief. 0.25. What is the ratio of the Value added (current US$) in Middle East & North Africa (developing only) in 2002 to that in 2008?
Provide a succinct answer. 0.31. What is the ratio of the Value added (current US$) in Grenada in 2002 to that in 2008?
Offer a very short reply. 0.62. What is the ratio of the Value added (current US$) in Paraguay in 2002 to that in 2008?
Make the answer very short. 0.48. What is the ratio of the Value added (current US$) of Fragile and conflict affected situations in 2003 to that in 2004?
Give a very brief answer. 0.77. What is the ratio of the Value added (current US$) of Middle East & North Africa (developing only) in 2003 to that in 2004?
Your answer should be very brief. 0.83. What is the ratio of the Value added (current US$) of Grenada in 2003 to that in 2004?
Give a very brief answer. 1. What is the ratio of the Value added (current US$) of Paraguay in 2003 to that in 2004?
Make the answer very short. 0.89. What is the ratio of the Value added (current US$) in Fragile and conflict affected situations in 2003 to that in 2005?
Offer a very short reply. 0.58. What is the ratio of the Value added (current US$) of Middle East & North Africa (developing only) in 2003 to that in 2005?
Your answer should be very brief. 0.66. What is the ratio of the Value added (current US$) of Grenada in 2003 to that in 2005?
Ensure brevity in your answer.  0.63. What is the ratio of the Value added (current US$) in Paraguay in 2003 to that in 2005?
Make the answer very short. 0.82. What is the ratio of the Value added (current US$) in Fragile and conflict affected situations in 2003 to that in 2006?
Offer a very short reply. 0.48. What is the ratio of the Value added (current US$) of Middle East & North Africa (developing only) in 2003 to that in 2006?
Provide a short and direct response. 0.56. What is the ratio of the Value added (current US$) in Grenada in 2003 to that in 2006?
Your answer should be very brief. 0.74. What is the ratio of the Value added (current US$) in Paraguay in 2003 to that in 2006?
Keep it short and to the point. 0.7. What is the ratio of the Value added (current US$) of Fragile and conflict affected situations in 2003 to that in 2007?
Ensure brevity in your answer.  0.4. What is the ratio of the Value added (current US$) of Middle East & North Africa (developing only) in 2003 to that in 2007?
Provide a succinct answer. 0.46. What is the ratio of the Value added (current US$) of Grenada in 2003 to that in 2007?
Offer a terse response. 0.7. What is the ratio of the Value added (current US$) of Paraguay in 2003 to that in 2007?
Give a very brief answer. 0.57. What is the ratio of the Value added (current US$) of Fragile and conflict affected situations in 2003 to that in 2008?
Offer a very short reply. 0.29. What is the ratio of the Value added (current US$) of Middle East & North Africa (developing only) in 2003 to that in 2008?
Offer a terse response. 0.36. What is the ratio of the Value added (current US$) of Grenada in 2003 to that in 2008?
Your answer should be compact. 0.69. What is the ratio of the Value added (current US$) of Paraguay in 2003 to that in 2008?
Provide a short and direct response. 0.45. What is the ratio of the Value added (current US$) of Fragile and conflict affected situations in 2004 to that in 2005?
Your response must be concise. 0.76. What is the ratio of the Value added (current US$) in Middle East & North Africa (developing only) in 2004 to that in 2005?
Offer a very short reply. 0.79. What is the ratio of the Value added (current US$) of Grenada in 2004 to that in 2005?
Keep it short and to the point. 0.63. What is the ratio of the Value added (current US$) in Paraguay in 2004 to that in 2005?
Provide a succinct answer. 0.91. What is the ratio of the Value added (current US$) in Fragile and conflict affected situations in 2004 to that in 2006?
Give a very brief answer. 0.63. What is the ratio of the Value added (current US$) in Middle East & North Africa (developing only) in 2004 to that in 2006?
Provide a succinct answer. 0.67. What is the ratio of the Value added (current US$) in Grenada in 2004 to that in 2006?
Provide a short and direct response. 0.74. What is the ratio of the Value added (current US$) of Paraguay in 2004 to that in 2006?
Provide a succinct answer. 0.78. What is the ratio of the Value added (current US$) of Fragile and conflict affected situations in 2004 to that in 2007?
Provide a succinct answer. 0.52. What is the ratio of the Value added (current US$) in Middle East & North Africa (developing only) in 2004 to that in 2007?
Offer a terse response. 0.55. What is the ratio of the Value added (current US$) in Grenada in 2004 to that in 2007?
Offer a very short reply. 0.7. What is the ratio of the Value added (current US$) of Paraguay in 2004 to that in 2007?
Provide a short and direct response. 0.64. What is the ratio of the Value added (current US$) of Fragile and conflict affected situations in 2004 to that in 2008?
Make the answer very short. 0.38. What is the ratio of the Value added (current US$) of Middle East & North Africa (developing only) in 2004 to that in 2008?
Ensure brevity in your answer.  0.43. What is the ratio of the Value added (current US$) of Grenada in 2004 to that in 2008?
Give a very brief answer. 0.69. What is the ratio of the Value added (current US$) of Paraguay in 2004 to that in 2008?
Your answer should be compact. 0.51. What is the ratio of the Value added (current US$) of Fragile and conflict affected situations in 2005 to that in 2006?
Make the answer very short. 0.83. What is the ratio of the Value added (current US$) in Middle East & North Africa (developing only) in 2005 to that in 2006?
Your response must be concise. 0.85. What is the ratio of the Value added (current US$) of Grenada in 2005 to that in 2006?
Provide a succinct answer. 1.17. What is the ratio of the Value added (current US$) of Paraguay in 2005 to that in 2006?
Your response must be concise. 0.86. What is the ratio of the Value added (current US$) in Fragile and conflict affected situations in 2005 to that in 2007?
Provide a short and direct response. 0.68. What is the ratio of the Value added (current US$) of Middle East & North Africa (developing only) in 2005 to that in 2007?
Provide a succinct answer. 0.69. What is the ratio of the Value added (current US$) of Grenada in 2005 to that in 2007?
Keep it short and to the point. 1.11. What is the ratio of the Value added (current US$) in Paraguay in 2005 to that in 2007?
Your answer should be compact. 0.7. What is the ratio of the Value added (current US$) in Fragile and conflict affected situations in 2005 to that in 2008?
Provide a succinct answer. 0.5. What is the ratio of the Value added (current US$) of Middle East & North Africa (developing only) in 2005 to that in 2008?
Provide a short and direct response. 0.55. What is the ratio of the Value added (current US$) of Grenada in 2005 to that in 2008?
Your answer should be compact. 1.1. What is the ratio of the Value added (current US$) in Paraguay in 2005 to that in 2008?
Give a very brief answer. 0.56. What is the ratio of the Value added (current US$) of Fragile and conflict affected situations in 2006 to that in 2007?
Provide a succinct answer. 0.82. What is the ratio of the Value added (current US$) in Middle East & North Africa (developing only) in 2006 to that in 2007?
Offer a very short reply. 0.82. What is the ratio of the Value added (current US$) of Grenada in 2006 to that in 2007?
Give a very brief answer. 0.95. What is the ratio of the Value added (current US$) in Paraguay in 2006 to that in 2007?
Your response must be concise. 0.81. What is the ratio of the Value added (current US$) of Fragile and conflict affected situations in 2006 to that in 2008?
Ensure brevity in your answer.  0.61. What is the ratio of the Value added (current US$) of Middle East & North Africa (developing only) in 2006 to that in 2008?
Make the answer very short. 0.65. What is the ratio of the Value added (current US$) in Grenada in 2006 to that in 2008?
Ensure brevity in your answer.  0.94. What is the ratio of the Value added (current US$) in Paraguay in 2006 to that in 2008?
Give a very brief answer. 0.65. What is the ratio of the Value added (current US$) in Fragile and conflict affected situations in 2007 to that in 2008?
Your answer should be very brief. 0.74. What is the ratio of the Value added (current US$) of Middle East & North Africa (developing only) in 2007 to that in 2008?
Your answer should be very brief. 0.79. What is the ratio of the Value added (current US$) in Grenada in 2007 to that in 2008?
Your answer should be compact. 0.98. What is the ratio of the Value added (current US$) of Paraguay in 2007 to that in 2008?
Keep it short and to the point. 0.8. What is the difference between the highest and the second highest Value added (current US$) in Fragile and conflict affected situations?
Provide a short and direct response. 6.40e+1. What is the difference between the highest and the second highest Value added (current US$) in Middle East & North Africa (developing only)?
Provide a short and direct response. 1.20e+11. What is the difference between the highest and the second highest Value added (current US$) of Grenada?
Your answer should be compact. 1.39e+07. What is the difference between the highest and the second highest Value added (current US$) of Paraguay?
Your answer should be very brief. 1.01e+09. What is the difference between the highest and the lowest Value added (current US$) of Fragile and conflict affected situations?
Ensure brevity in your answer.  1.85e+11. What is the difference between the highest and the lowest Value added (current US$) of Middle East & North Africa (developing only)?
Keep it short and to the point. 3.95e+11. What is the difference between the highest and the lowest Value added (current US$) of Grenada?
Ensure brevity in your answer.  6.91e+07. What is the difference between the highest and the lowest Value added (current US$) of Paraguay?
Your answer should be very brief. 2.74e+09. 